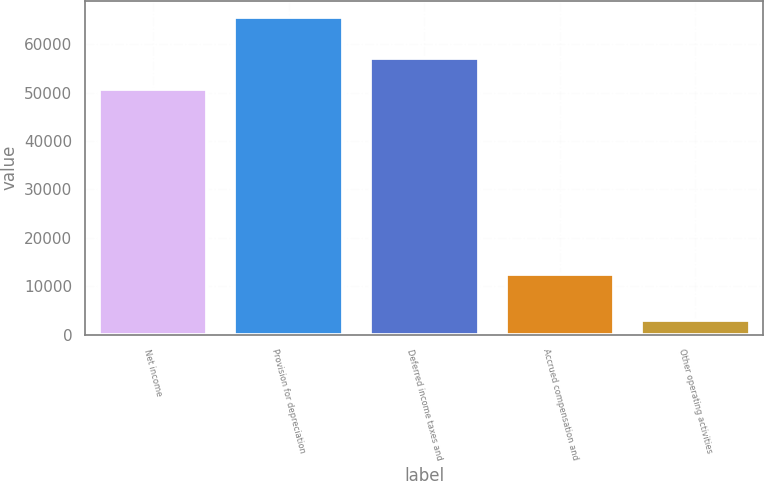Convert chart to OTSL. <chart><loc_0><loc_0><loc_500><loc_500><bar_chart><fcel>Net income<fcel>Provision for depreciation<fcel>Deferred income taxes and<fcel>Accrued compensation and<fcel>Other operating activities<nl><fcel>50798<fcel>65637<fcel>57051.3<fcel>12529<fcel>3104<nl></chart> 